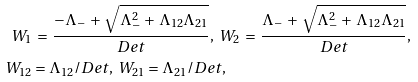<formula> <loc_0><loc_0><loc_500><loc_500>W _ { 1 } & \, = \, \frac { - \Lambda _ { - } \, + \, \sqrt { \Lambda _ { - } ^ { 2 } \, + \, \Lambda _ { 1 2 } \Lambda _ { 2 1 } } } { D e t } , \ W _ { 2 } \, = \, \frac { \Lambda _ { - } \, + \, \sqrt { \Lambda _ { - } ^ { 2 } \, + \, \Lambda _ { 1 2 } \Lambda _ { 2 1 } } } { D e t } , \\ W _ { 1 2 } & = \Lambda _ { 1 2 } / D e t , \ W _ { 2 1 } = \Lambda _ { 2 1 } / D e t ,</formula> 